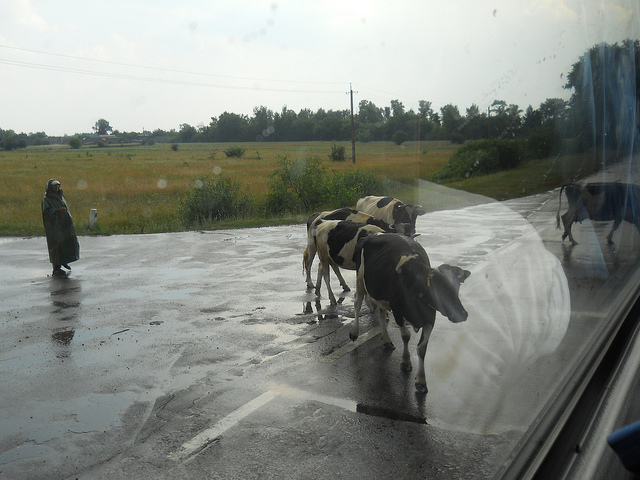How many cows are visible? There are three cows visibly present, each showing distinctive black and white markings, walking on what appears to be a wet road. 